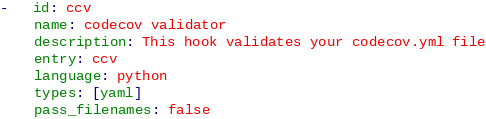<code> <loc_0><loc_0><loc_500><loc_500><_YAML_>-   id: ccv
    name: codecov validator
    description: This hook validates your codecov.yml file
    entry: ccv
    language: python
    types: [yaml]
    pass_filenames: false
</code> 